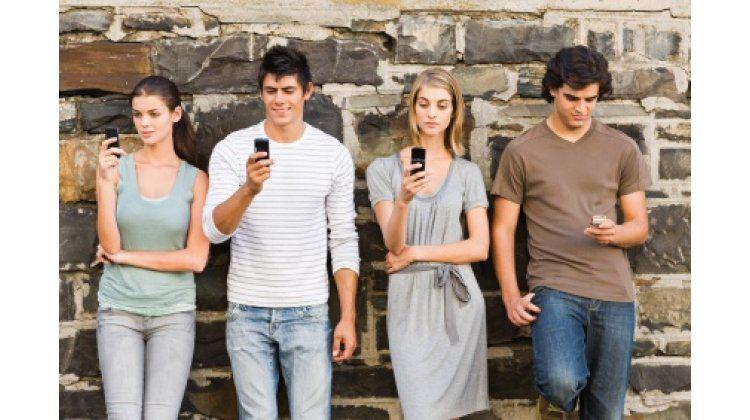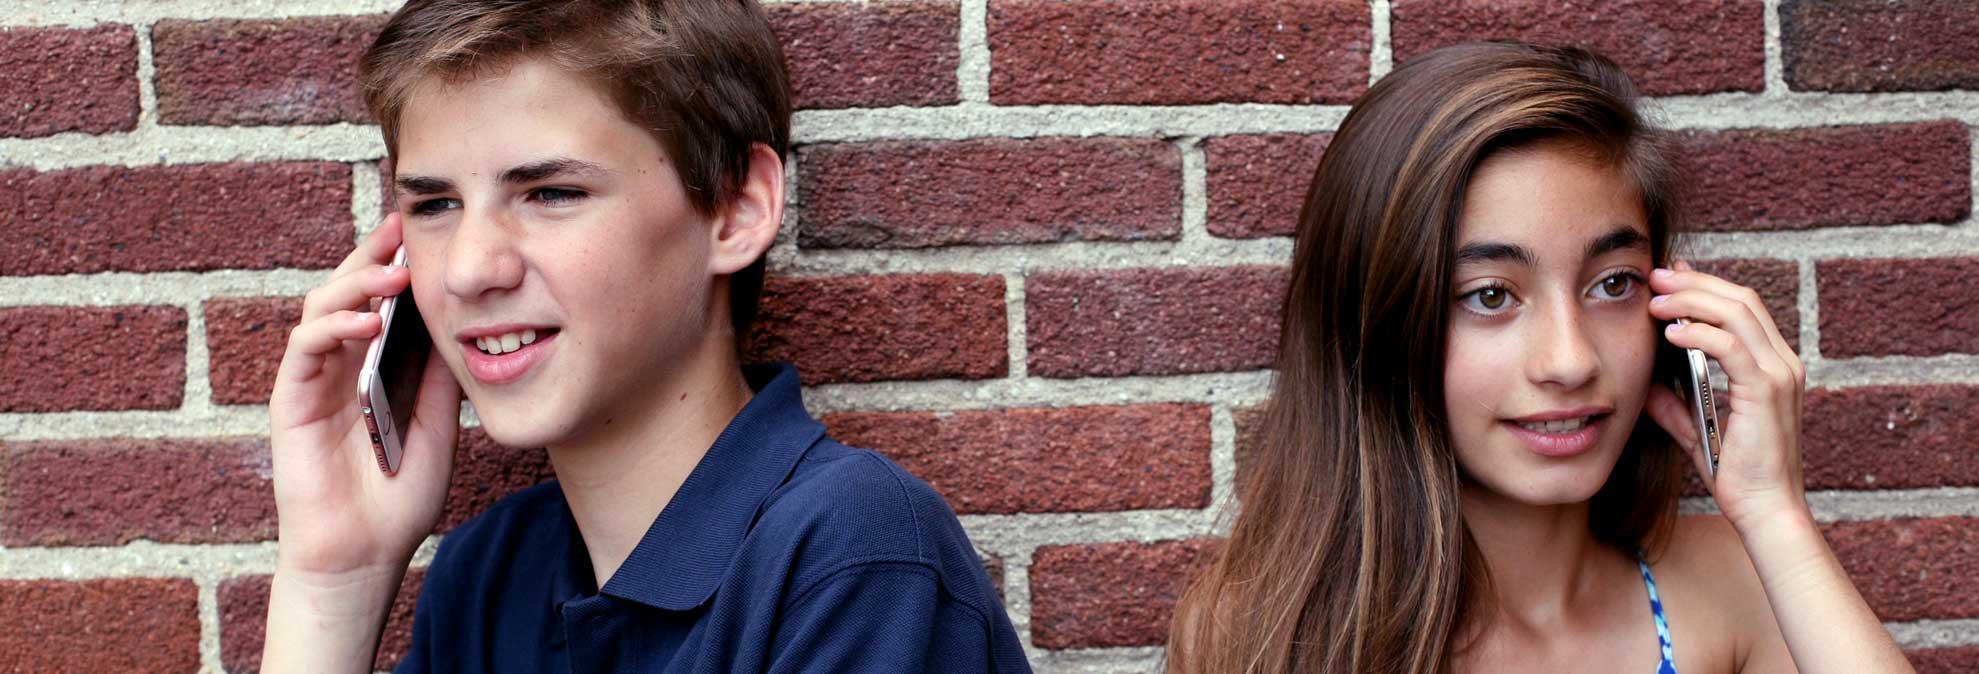The first image is the image on the left, the second image is the image on the right. For the images displayed, is the sentence "In the right image people are talking on their phones." factually correct? Answer yes or no. Yes. The first image is the image on the left, the second image is the image on the right. Considering the images on both sides, is "An image shows four people standing in a line in front of a brick wall checking their phones." valid? Answer yes or no. Yes. 